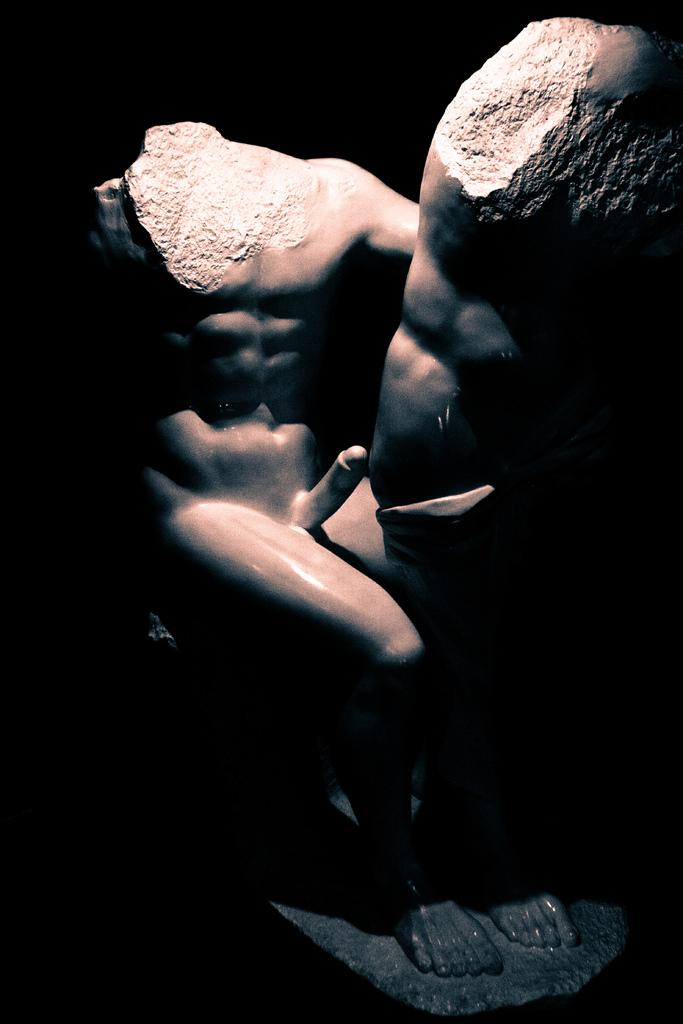What is the main subject of the image? There is a sculpture in the image. What type of horn can be seen on the sculpture in the image? There is no horn present on the sculpture in the image. 